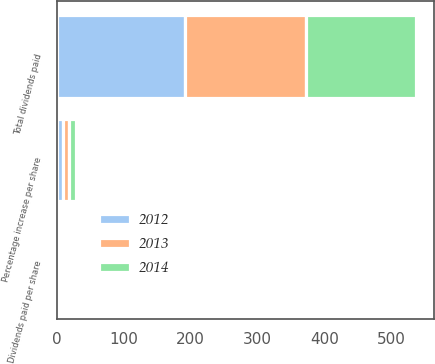Convert chart to OTSL. <chart><loc_0><loc_0><loc_500><loc_500><stacked_bar_chart><ecel><fcel>Total dividends paid<fcel>Dividends paid per share<fcel>Percentage increase per share<nl><fcel>2012<fcel>192.4<fcel>1.48<fcel>8.8<nl><fcel>2013<fcel>179.9<fcel>1.36<fcel>9.7<nl><fcel>2014<fcel>164.7<fcel>1.24<fcel>10.7<nl></chart> 